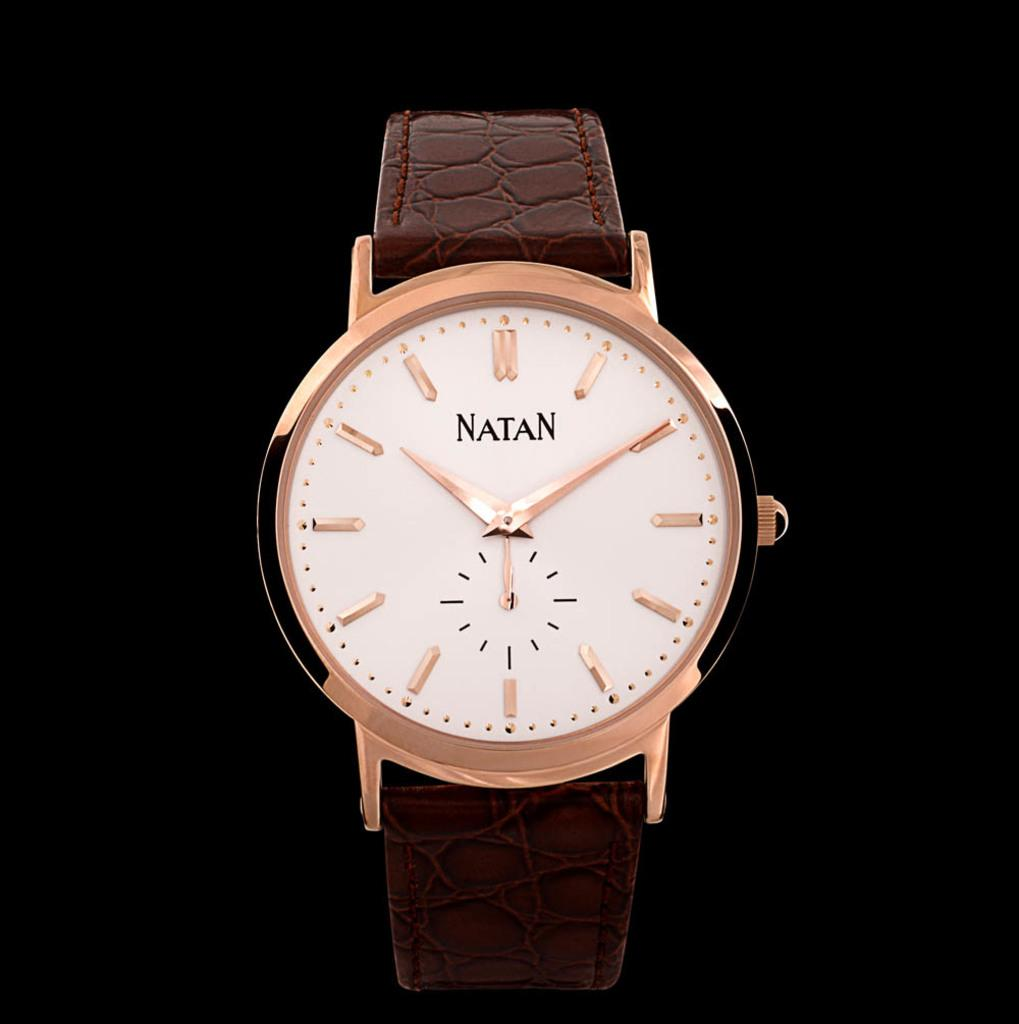<image>
Relay a brief, clear account of the picture shown. Gold and white wristwatch which says NATAN with a brown strap. 